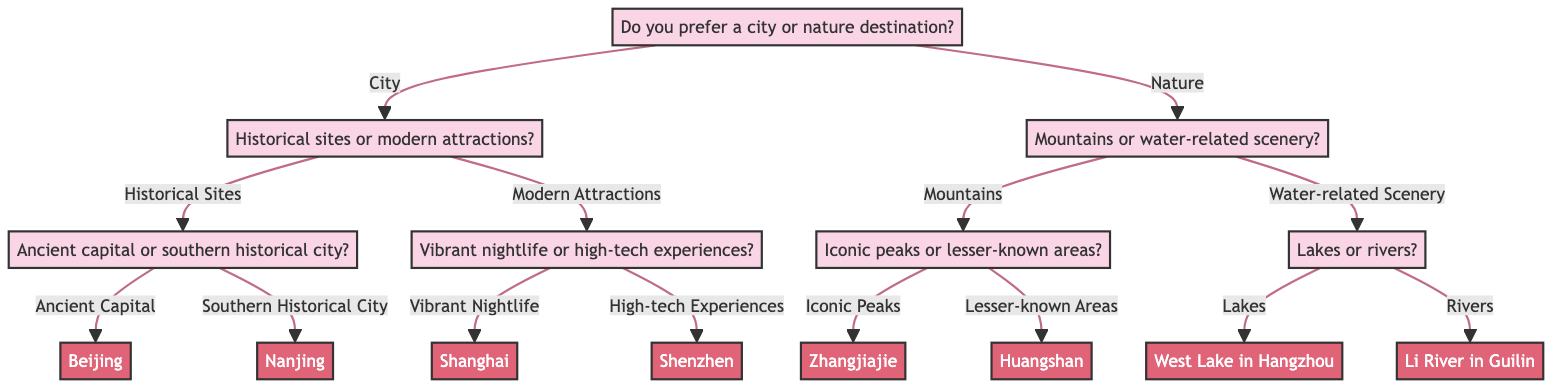What is the first question in the diagram? The first question presented in the diagram is "Do you prefer a city or nature destination?" It serves as the initial decision point that branches into two main categories: City and Nature.
Answer: Do you prefer a city or nature destination? How many destination options are available in the diagram? The diagram has a total of six destinations listed at the end of various branches of the decision tree: Beijing, Nanjing, Shanghai, Shenzhen, Zhangjiajie, Huangshan, West Lake in Hangzhou, and Li River in Guilin. Counting these, we find there are eight distinct destination options.
Answer: Eight If a person chooses "Modern Attractions," what are the two follow-up options they will encounter? After selecting "Modern Attractions," the next options provided are "Vibrant Nightlife" and "High-tech Experiences." These options represent further distinctions within the category of modern attractions before arriving at specific destinations.
Answer: Vibrant Nightlife and High-tech Experiences What destination corresponds to the choice of "Ancient Capital"? The "Ancient Capital" option specifically leads to the destination "Beijing" in the diagram. This connection illustrates a direct line from one of the historical site options to a notable city in China.
Answer: Beijing What do you get if you choose "Nature" and then "Mountains"? Upon choosing "Nature," if you continue by selecting "Mountains," you will face another question that divides into "Iconic Peaks" or "Lesser-known Areas." The eventual destinations for this pathway are Zhangjiajie for iconic peaks or Huangshan for lesser-known areas.
Answer: Zhangjiajie or Huangshan If someone decides on "Water-related Scenery" and selects "Lakes," which destination will they reach? Choosing "Water-related Scenery" and subsequently selecting "Lakes" leads directly to the destination "West Lake in Hangzhou." This shows the specific destination linked to the water-related options presented in the diagram.
Answer: West Lake in Hangzhou What does the option "Vibrant Nightlife" lead to? The option "Vibrant Nightlife" directly leads to the destination "Shanghai" in the decision tree. This path indicates that those interested in vibrant nightlife can anticipate traveling to one of China's most bustling cities.
Answer: Shanghai Which destination is associated with "Rivers"? The choice "Rivers" ultimately leads to the destination "Li River in Guilin." This reflects a specific water-related destination in China associated with scenic river views.
Answer: Li River in Guilin 